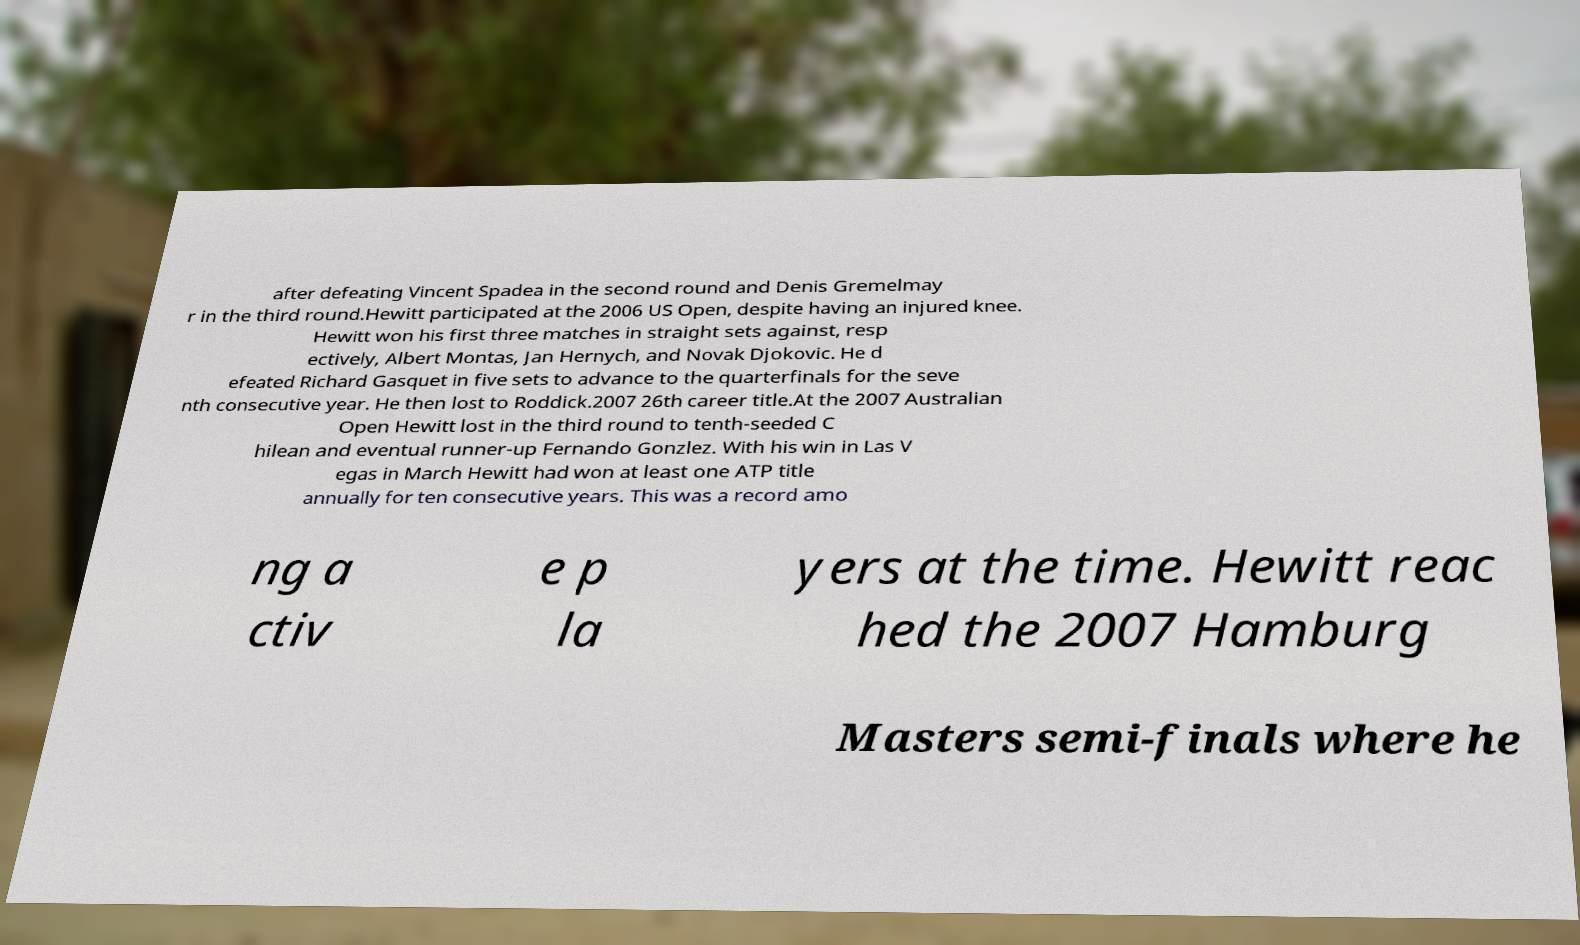Could you assist in decoding the text presented in this image and type it out clearly? after defeating Vincent Spadea in the second round and Denis Gremelmay r in the third round.Hewitt participated at the 2006 US Open, despite having an injured knee. Hewitt won his first three matches in straight sets against, resp ectively, Albert Montas, Jan Hernych, and Novak Djokovic. He d efeated Richard Gasquet in five sets to advance to the quarterfinals for the seve nth consecutive year. He then lost to Roddick.2007 26th career title.At the 2007 Australian Open Hewitt lost in the third round to tenth-seeded C hilean and eventual runner-up Fernando Gonzlez. With his win in Las V egas in March Hewitt had won at least one ATP title annually for ten consecutive years. This was a record amo ng a ctiv e p la yers at the time. Hewitt reac hed the 2007 Hamburg Masters semi-finals where he 